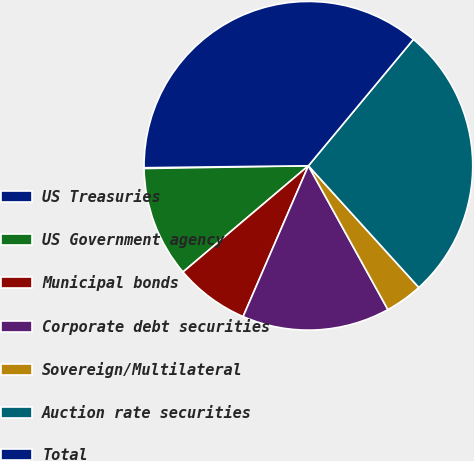Convert chart to OTSL. <chart><loc_0><loc_0><loc_500><loc_500><pie_chart><fcel>US Treasuries<fcel>US Government agency<fcel>Municipal bonds<fcel>Corporate debt securities<fcel>Sovereign/Multilateral<fcel>Auction rate securities<fcel>Total<nl><fcel>0.08%<fcel>10.92%<fcel>7.31%<fcel>14.54%<fcel>3.69%<fcel>27.24%<fcel>36.22%<nl></chart> 